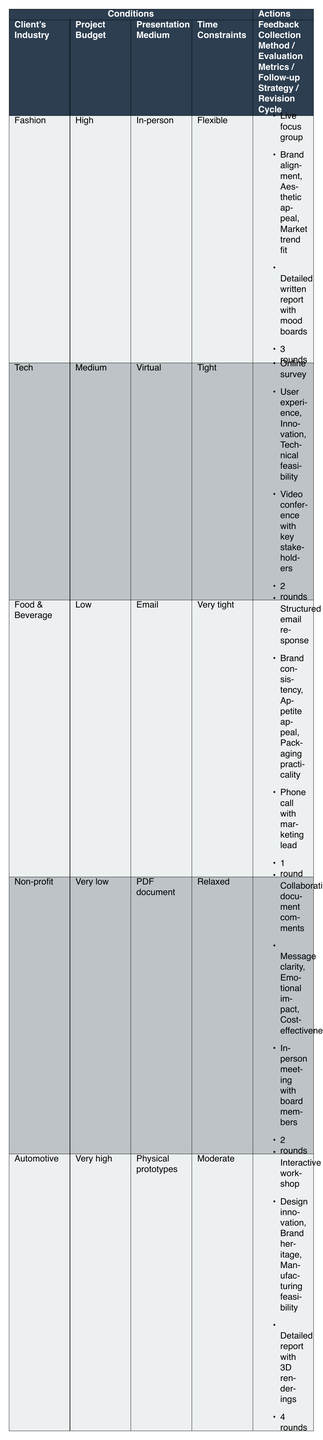What is the feedback collection method for the Food & Beverage industry? The table indicates that the feedback collection method for the Food & Beverage industry is "Structured email response" as seen in the relevant row.
Answer: Structured email response What are the evaluation metrics used for the Automotive industry? According to the table, the evaluation metrics for the Automotive industry include "Design innovation, Brand heritage, Manufacturing feasibility" which are listed in the corresponding row.
Answer: Design innovation, Brand heritage, Manufacturing feasibility Is there a client in the Tech industry with a project budget categorized as High? By reviewing the table, we can see that no client in the Tech industry has a project budget categorized as High; instead, it is listed as Medium.
Answer: No What is the average number of revision cycles across all industries? The revision cycles are as follows: Fashion (3), Tech (2), Food & Beverage (1), Non-profit (2), Automotive (4). Adding these gives a total of 12, and there are 5 clients, thus the average is 12 / 5 = 2.4.
Answer: 2.4 Which industries have a Flexible time constraint and what is their revision cycle? From the table, only the Fashion industry has a Flexible time constraint, and its revision cycle is 3 rounds. This can be confirmed by checking the relevant column under Flexible time constraints.
Answer: Fashion, 3 rounds What follow-up strategy is employed for projects with a Low budget? The follow-up strategy for the Food & Beverage industry, which has a Low budget, is "Phone call with marketing lead" as stated in the feedback collection section of that row.
Answer: Phone call with marketing lead Is the feedback collection method for the Non-profit industry different from the one used in the Tech industry? The Non-profit industry uses "Collaborative document comments" as a feedback collection method, while the Tech industry uses "Online survey." Since these methods are different, the answer is yes.
Answer: Yes Which industry has the tightest time constraints, and what is the evaluation metric used? The Food & Beverage industry is the one with the tightest time constraints, described as "Very tight." Its evaluation metrics are listed as "Brand consistency, Appetite appeal, Packaging practicality."
Answer: Food & Beverage, Brand consistency, Appetite appeal, Packaging practicality What is the project budget status for the client in the Fashion industry? The project budget for the Fashion industry is categorized as High according to the specific row in the table.
Answer: High 